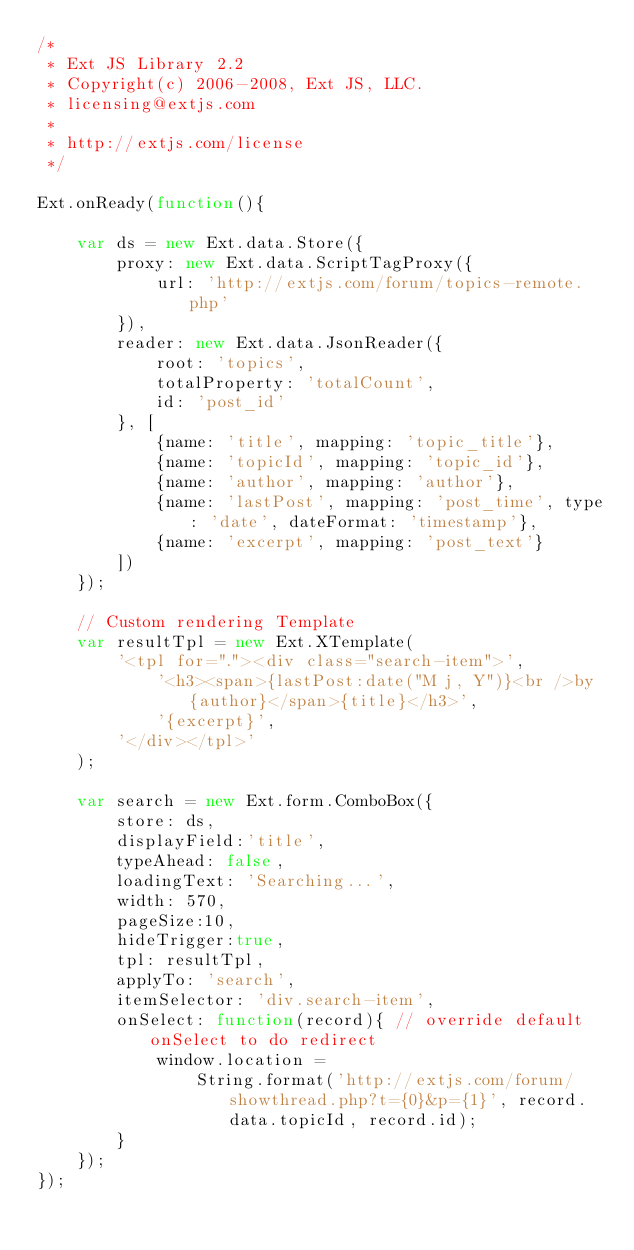<code> <loc_0><loc_0><loc_500><loc_500><_JavaScript_>/*
 * Ext JS Library 2.2
 * Copyright(c) 2006-2008, Ext JS, LLC.
 * licensing@extjs.com
 * 
 * http://extjs.com/license
 */

Ext.onReady(function(){

    var ds = new Ext.data.Store({
        proxy: new Ext.data.ScriptTagProxy({
            url: 'http://extjs.com/forum/topics-remote.php'
        }),
        reader: new Ext.data.JsonReader({
            root: 'topics',
            totalProperty: 'totalCount',
            id: 'post_id'
        }, [
            {name: 'title', mapping: 'topic_title'},
            {name: 'topicId', mapping: 'topic_id'},
            {name: 'author', mapping: 'author'},
            {name: 'lastPost', mapping: 'post_time', type: 'date', dateFormat: 'timestamp'},
            {name: 'excerpt', mapping: 'post_text'}
        ])
    });

    // Custom rendering Template
    var resultTpl = new Ext.XTemplate(
        '<tpl for="."><div class="search-item">',
            '<h3><span>{lastPost:date("M j, Y")}<br />by {author}</span>{title}</h3>',
            '{excerpt}',
        '</div></tpl>'
    );
    
    var search = new Ext.form.ComboBox({
        store: ds,
        displayField:'title',
        typeAhead: false,
        loadingText: 'Searching...',
        width: 570,
        pageSize:10,
        hideTrigger:true,
        tpl: resultTpl,
        applyTo: 'search',
        itemSelector: 'div.search-item',
        onSelect: function(record){ // override default onSelect to do redirect
            window.location =
                String.format('http://extjs.com/forum/showthread.php?t={0}&p={1}', record.data.topicId, record.id);
        }
    });
});</code> 